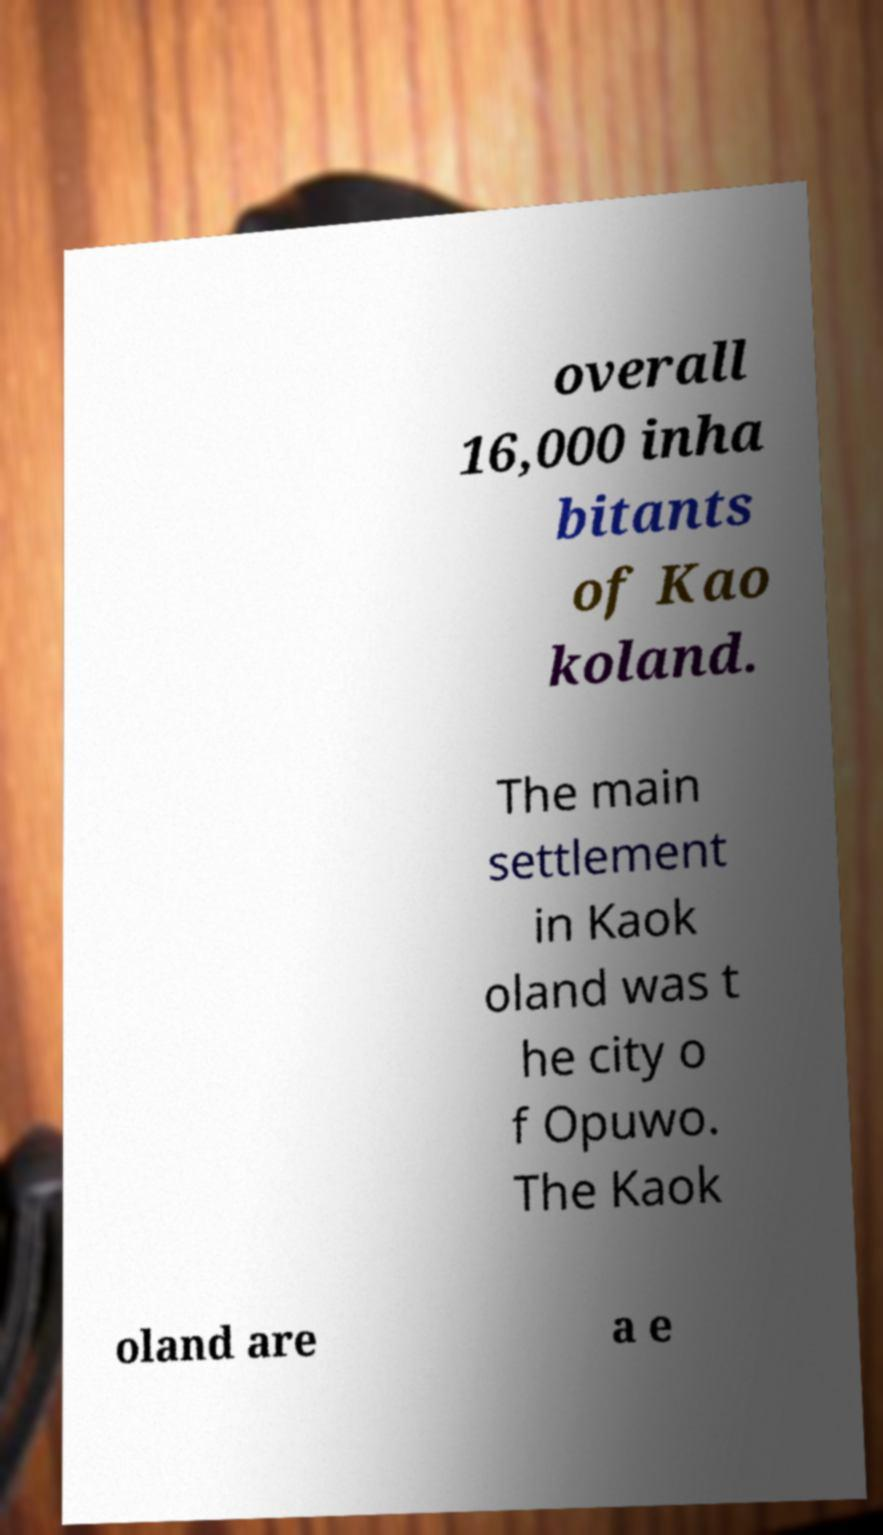For documentation purposes, I need the text within this image transcribed. Could you provide that? overall 16,000 inha bitants of Kao koland. The main settlement in Kaok oland was t he city o f Opuwo. The Kaok oland are a e 